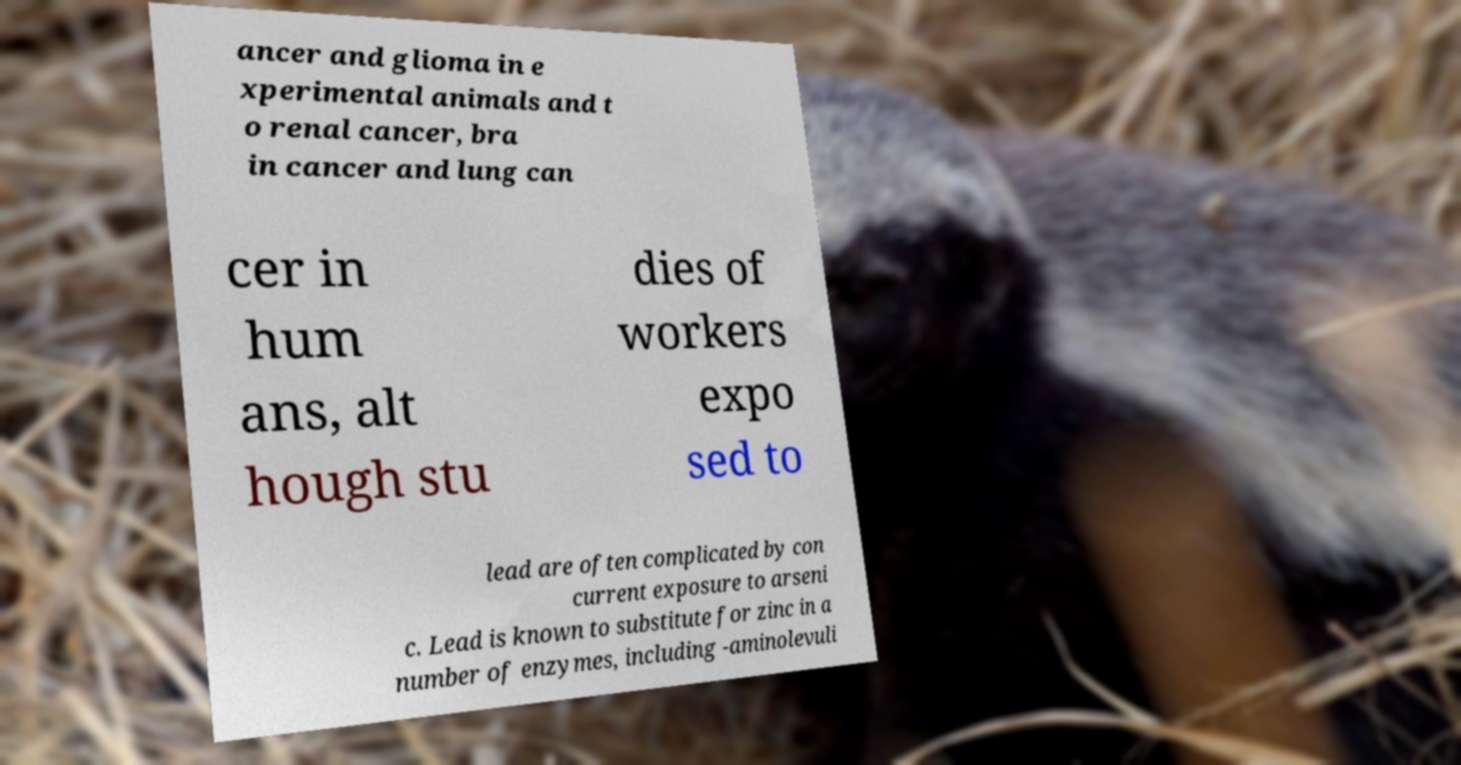Could you extract and type out the text from this image? ancer and glioma in e xperimental animals and t o renal cancer, bra in cancer and lung can cer in hum ans, alt hough stu dies of workers expo sed to lead are often complicated by con current exposure to arseni c. Lead is known to substitute for zinc in a number of enzymes, including -aminolevuli 